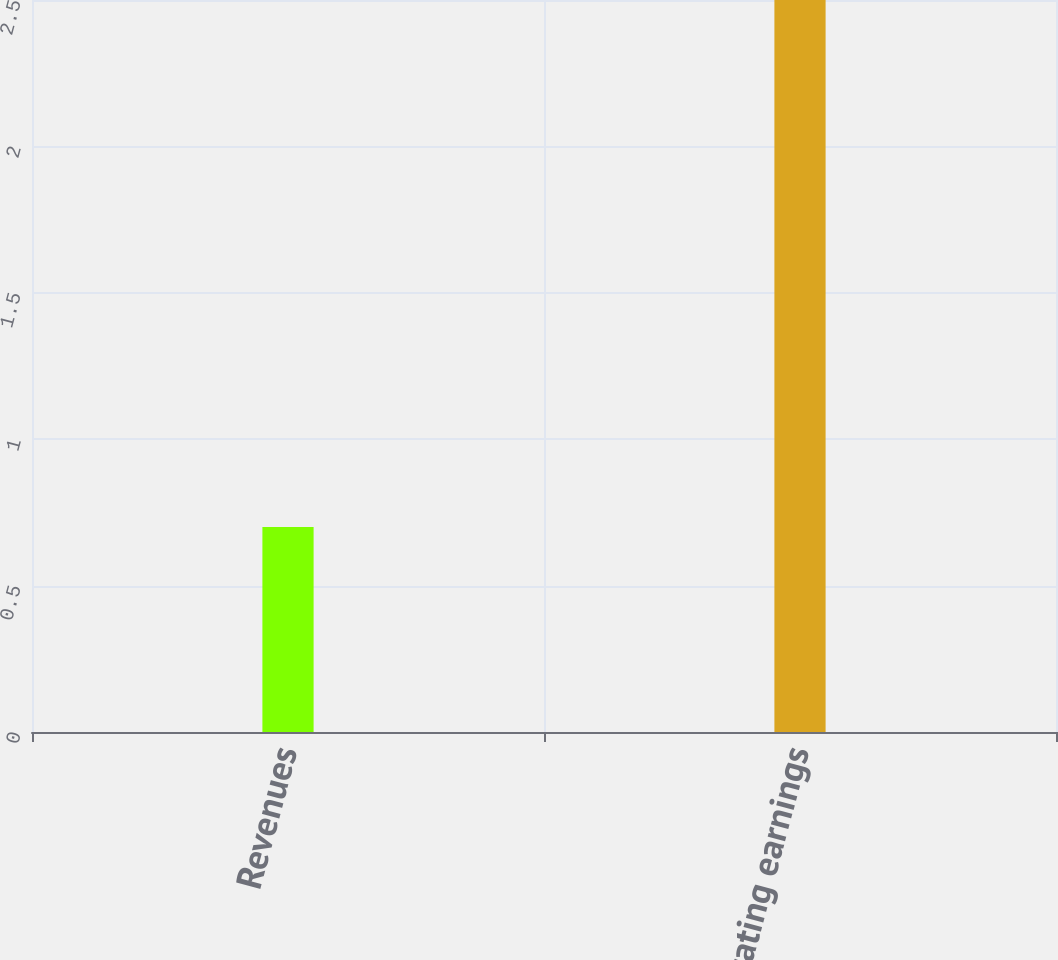Convert chart. <chart><loc_0><loc_0><loc_500><loc_500><bar_chart><fcel>Revenues<fcel>Operating earnings<nl><fcel>0.7<fcel>2.5<nl></chart> 